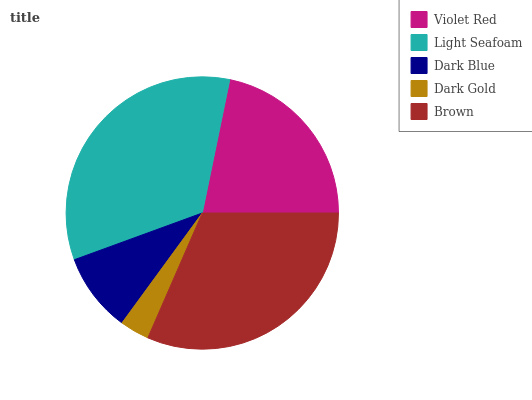Is Dark Gold the minimum?
Answer yes or no. Yes. Is Light Seafoam the maximum?
Answer yes or no. Yes. Is Dark Blue the minimum?
Answer yes or no. No. Is Dark Blue the maximum?
Answer yes or no. No. Is Light Seafoam greater than Dark Blue?
Answer yes or no. Yes. Is Dark Blue less than Light Seafoam?
Answer yes or no. Yes. Is Dark Blue greater than Light Seafoam?
Answer yes or no. No. Is Light Seafoam less than Dark Blue?
Answer yes or no. No. Is Violet Red the high median?
Answer yes or no. Yes. Is Violet Red the low median?
Answer yes or no. Yes. Is Dark Gold the high median?
Answer yes or no. No. Is Dark Blue the low median?
Answer yes or no. No. 